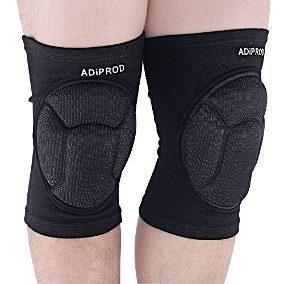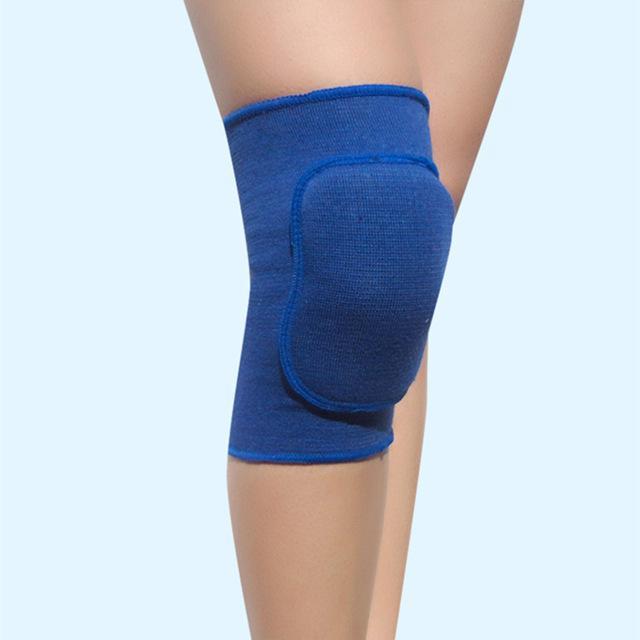The first image is the image on the left, the second image is the image on the right. For the images shown, is this caption "There is a single blue kneepad in one image and two black kneepads in the other image." true? Answer yes or no. Yes. The first image is the image on the left, the second image is the image on the right. Examine the images to the left and right. Is the description "Two black kneepads are modeled in one image, but a second image shows only one kneepad of a different color." accurate? Answer yes or no. Yes. 